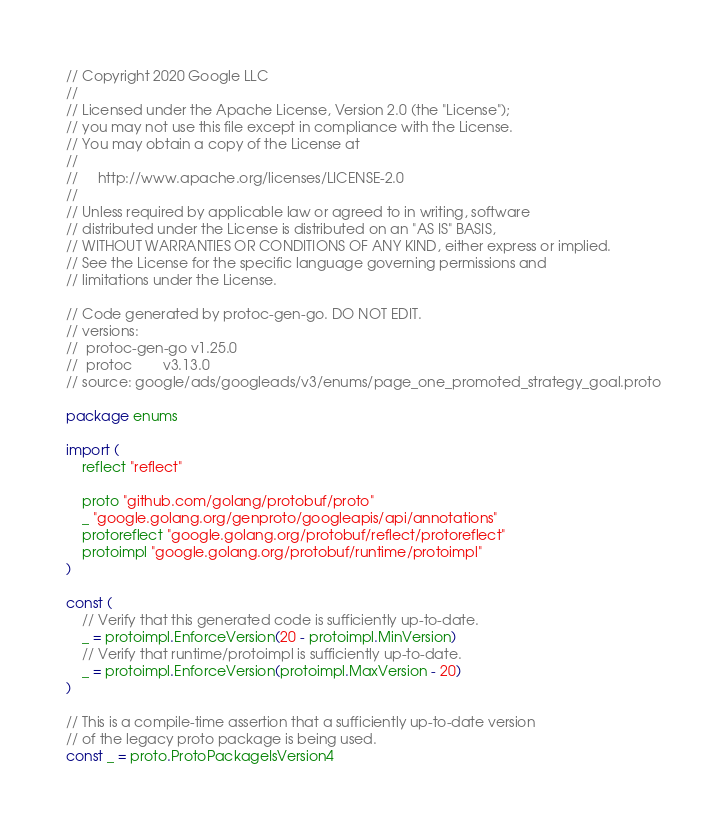Convert code to text. <code><loc_0><loc_0><loc_500><loc_500><_Go_>// Copyright 2020 Google LLC
//
// Licensed under the Apache License, Version 2.0 (the "License");
// you may not use this file except in compliance with the License.
// You may obtain a copy of the License at
//
//     http://www.apache.org/licenses/LICENSE-2.0
//
// Unless required by applicable law or agreed to in writing, software
// distributed under the License is distributed on an "AS IS" BASIS,
// WITHOUT WARRANTIES OR CONDITIONS OF ANY KIND, either express or implied.
// See the License for the specific language governing permissions and
// limitations under the License.

// Code generated by protoc-gen-go. DO NOT EDIT.
// versions:
// 	protoc-gen-go v1.25.0
// 	protoc        v3.13.0
// source: google/ads/googleads/v3/enums/page_one_promoted_strategy_goal.proto

package enums

import (
	reflect "reflect"

	proto "github.com/golang/protobuf/proto"
	_ "google.golang.org/genproto/googleapis/api/annotations"
	protoreflect "google.golang.org/protobuf/reflect/protoreflect"
	protoimpl "google.golang.org/protobuf/runtime/protoimpl"
)

const (
	// Verify that this generated code is sufficiently up-to-date.
	_ = protoimpl.EnforceVersion(20 - protoimpl.MinVersion)
	// Verify that runtime/protoimpl is sufficiently up-to-date.
	_ = protoimpl.EnforceVersion(protoimpl.MaxVersion - 20)
)

// This is a compile-time assertion that a sufficiently up-to-date version
// of the legacy proto package is being used.
const _ = proto.ProtoPackageIsVersion4
</code> 